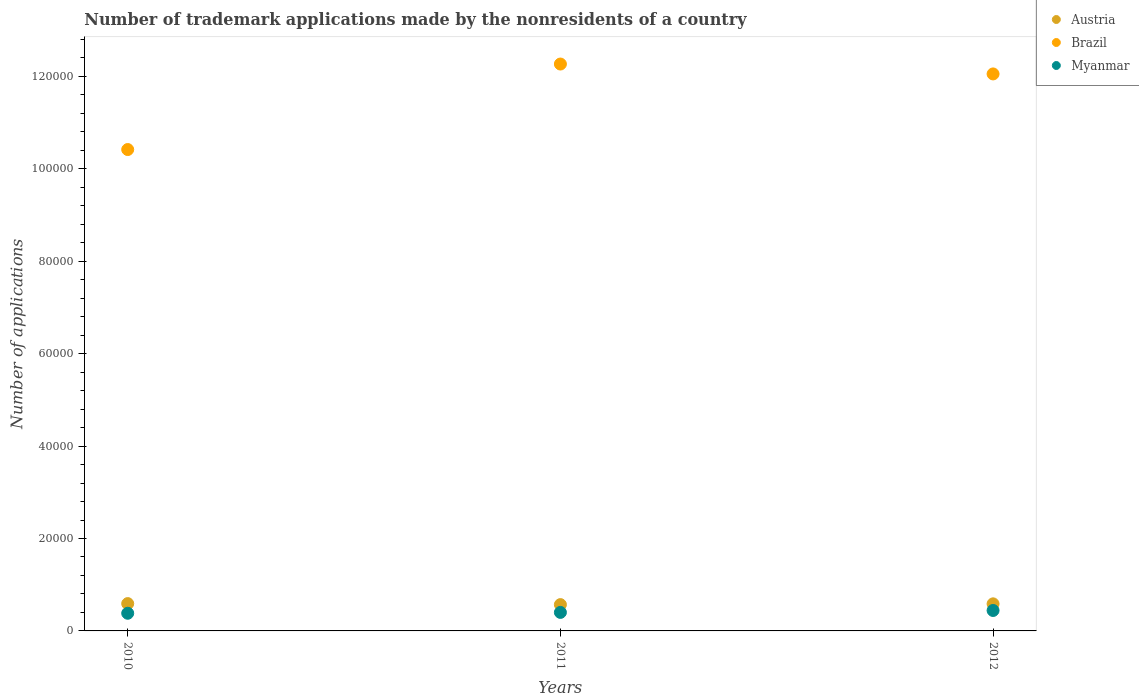Is the number of dotlines equal to the number of legend labels?
Your answer should be compact. Yes. What is the number of trademark applications made by the nonresidents in Myanmar in 2011?
Keep it short and to the point. 4007. Across all years, what is the maximum number of trademark applications made by the nonresidents in Myanmar?
Ensure brevity in your answer.  4422. Across all years, what is the minimum number of trademark applications made by the nonresidents in Austria?
Give a very brief answer. 5693. In which year was the number of trademark applications made by the nonresidents in Austria maximum?
Make the answer very short. 2010. What is the total number of trademark applications made by the nonresidents in Austria in the graph?
Offer a very short reply. 1.75e+04. What is the difference between the number of trademark applications made by the nonresidents in Austria in 2011 and that in 2012?
Your response must be concise. -167. What is the difference between the number of trademark applications made by the nonresidents in Austria in 2011 and the number of trademark applications made by the nonresidents in Myanmar in 2012?
Give a very brief answer. 1271. What is the average number of trademark applications made by the nonresidents in Brazil per year?
Offer a terse response. 1.16e+05. In the year 2010, what is the difference between the number of trademark applications made by the nonresidents in Myanmar and number of trademark applications made by the nonresidents in Brazil?
Your answer should be very brief. -1.00e+05. What is the ratio of the number of trademark applications made by the nonresidents in Brazil in 2010 to that in 2012?
Offer a terse response. 0.86. What is the difference between the highest and the second highest number of trademark applications made by the nonresidents in Brazil?
Keep it short and to the point. 2141. What is the difference between the highest and the lowest number of trademark applications made by the nonresidents in Myanmar?
Your answer should be compact. 601. In how many years, is the number of trademark applications made by the nonresidents in Austria greater than the average number of trademark applications made by the nonresidents in Austria taken over all years?
Provide a succinct answer. 2. Is the number of trademark applications made by the nonresidents in Brazil strictly greater than the number of trademark applications made by the nonresidents in Myanmar over the years?
Give a very brief answer. Yes. Is the number of trademark applications made by the nonresidents in Austria strictly less than the number of trademark applications made by the nonresidents in Myanmar over the years?
Provide a short and direct response. No. How many years are there in the graph?
Your response must be concise. 3. Are the values on the major ticks of Y-axis written in scientific E-notation?
Offer a terse response. No. Does the graph contain grids?
Your answer should be compact. No. How many legend labels are there?
Ensure brevity in your answer.  3. How are the legend labels stacked?
Offer a very short reply. Vertical. What is the title of the graph?
Offer a terse response. Number of trademark applications made by the nonresidents of a country. Does "Ecuador" appear as one of the legend labels in the graph?
Give a very brief answer. No. What is the label or title of the X-axis?
Your answer should be compact. Years. What is the label or title of the Y-axis?
Keep it short and to the point. Number of applications. What is the Number of applications in Austria in 2010?
Ensure brevity in your answer.  5911. What is the Number of applications of Brazil in 2010?
Your answer should be very brief. 1.04e+05. What is the Number of applications in Myanmar in 2010?
Your answer should be compact. 3821. What is the Number of applications in Austria in 2011?
Offer a terse response. 5693. What is the Number of applications of Brazil in 2011?
Give a very brief answer. 1.23e+05. What is the Number of applications of Myanmar in 2011?
Make the answer very short. 4007. What is the Number of applications in Austria in 2012?
Your answer should be very brief. 5860. What is the Number of applications in Brazil in 2012?
Your answer should be compact. 1.21e+05. What is the Number of applications in Myanmar in 2012?
Offer a very short reply. 4422. Across all years, what is the maximum Number of applications in Austria?
Give a very brief answer. 5911. Across all years, what is the maximum Number of applications in Brazil?
Your answer should be compact. 1.23e+05. Across all years, what is the maximum Number of applications in Myanmar?
Ensure brevity in your answer.  4422. Across all years, what is the minimum Number of applications of Austria?
Keep it short and to the point. 5693. Across all years, what is the minimum Number of applications in Brazil?
Your answer should be very brief. 1.04e+05. Across all years, what is the minimum Number of applications of Myanmar?
Your answer should be compact. 3821. What is the total Number of applications of Austria in the graph?
Provide a succinct answer. 1.75e+04. What is the total Number of applications in Brazil in the graph?
Your answer should be compact. 3.47e+05. What is the total Number of applications in Myanmar in the graph?
Your response must be concise. 1.22e+04. What is the difference between the Number of applications in Austria in 2010 and that in 2011?
Offer a very short reply. 218. What is the difference between the Number of applications in Brazil in 2010 and that in 2011?
Make the answer very short. -1.85e+04. What is the difference between the Number of applications in Myanmar in 2010 and that in 2011?
Your response must be concise. -186. What is the difference between the Number of applications in Austria in 2010 and that in 2012?
Keep it short and to the point. 51. What is the difference between the Number of applications of Brazil in 2010 and that in 2012?
Offer a very short reply. -1.64e+04. What is the difference between the Number of applications of Myanmar in 2010 and that in 2012?
Give a very brief answer. -601. What is the difference between the Number of applications in Austria in 2011 and that in 2012?
Provide a succinct answer. -167. What is the difference between the Number of applications in Brazil in 2011 and that in 2012?
Ensure brevity in your answer.  2141. What is the difference between the Number of applications in Myanmar in 2011 and that in 2012?
Give a very brief answer. -415. What is the difference between the Number of applications in Austria in 2010 and the Number of applications in Brazil in 2011?
Keep it short and to the point. -1.17e+05. What is the difference between the Number of applications in Austria in 2010 and the Number of applications in Myanmar in 2011?
Provide a short and direct response. 1904. What is the difference between the Number of applications in Brazil in 2010 and the Number of applications in Myanmar in 2011?
Your response must be concise. 1.00e+05. What is the difference between the Number of applications of Austria in 2010 and the Number of applications of Brazil in 2012?
Provide a short and direct response. -1.15e+05. What is the difference between the Number of applications in Austria in 2010 and the Number of applications in Myanmar in 2012?
Provide a short and direct response. 1489. What is the difference between the Number of applications of Brazil in 2010 and the Number of applications of Myanmar in 2012?
Provide a short and direct response. 9.97e+04. What is the difference between the Number of applications of Austria in 2011 and the Number of applications of Brazil in 2012?
Offer a terse response. -1.15e+05. What is the difference between the Number of applications of Austria in 2011 and the Number of applications of Myanmar in 2012?
Offer a terse response. 1271. What is the difference between the Number of applications in Brazil in 2011 and the Number of applications in Myanmar in 2012?
Your response must be concise. 1.18e+05. What is the average Number of applications of Austria per year?
Keep it short and to the point. 5821.33. What is the average Number of applications of Brazil per year?
Offer a very short reply. 1.16e+05. What is the average Number of applications in Myanmar per year?
Ensure brevity in your answer.  4083.33. In the year 2010, what is the difference between the Number of applications in Austria and Number of applications in Brazil?
Offer a very short reply. -9.83e+04. In the year 2010, what is the difference between the Number of applications in Austria and Number of applications in Myanmar?
Your answer should be very brief. 2090. In the year 2010, what is the difference between the Number of applications of Brazil and Number of applications of Myanmar?
Your response must be concise. 1.00e+05. In the year 2011, what is the difference between the Number of applications of Austria and Number of applications of Brazil?
Provide a succinct answer. -1.17e+05. In the year 2011, what is the difference between the Number of applications in Austria and Number of applications in Myanmar?
Your answer should be compact. 1686. In the year 2011, what is the difference between the Number of applications of Brazil and Number of applications of Myanmar?
Your answer should be compact. 1.19e+05. In the year 2012, what is the difference between the Number of applications of Austria and Number of applications of Brazil?
Offer a very short reply. -1.15e+05. In the year 2012, what is the difference between the Number of applications of Austria and Number of applications of Myanmar?
Offer a very short reply. 1438. In the year 2012, what is the difference between the Number of applications in Brazil and Number of applications in Myanmar?
Offer a terse response. 1.16e+05. What is the ratio of the Number of applications of Austria in 2010 to that in 2011?
Give a very brief answer. 1.04. What is the ratio of the Number of applications of Brazil in 2010 to that in 2011?
Your answer should be compact. 0.85. What is the ratio of the Number of applications of Myanmar in 2010 to that in 2011?
Ensure brevity in your answer.  0.95. What is the ratio of the Number of applications of Austria in 2010 to that in 2012?
Your answer should be compact. 1.01. What is the ratio of the Number of applications in Brazil in 2010 to that in 2012?
Give a very brief answer. 0.86. What is the ratio of the Number of applications in Myanmar in 2010 to that in 2012?
Your response must be concise. 0.86. What is the ratio of the Number of applications in Austria in 2011 to that in 2012?
Offer a very short reply. 0.97. What is the ratio of the Number of applications in Brazil in 2011 to that in 2012?
Offer a very short reply. 1.02. What is the ratio of the Number of applications in Myanmar in 2011 to that in 2012?
Provide a succinct answer. 0.91. What is the difference between the highest and the second highest Number of applications of Austria?
Provide a short and direct response. 51. What is the difference between the highest and the second highest Number of applications of Brazil?
Ensure brevity in your answer.  2141. What is the difference between the highest and the second highest Number of applications in Myanmar?
Offer a terse response. 415. What is the difference between the highest and the lowest Number of applications in Austria?
Ensure brevity in your answer.  218. What is the difference between the highest and the lowest Number of applications of Brazil?
Your answer should be compact. 1.85e+04. What is the difference between the highest and the lowest Number of applications of Myanmar?
Provide a short and direct response. 601. 